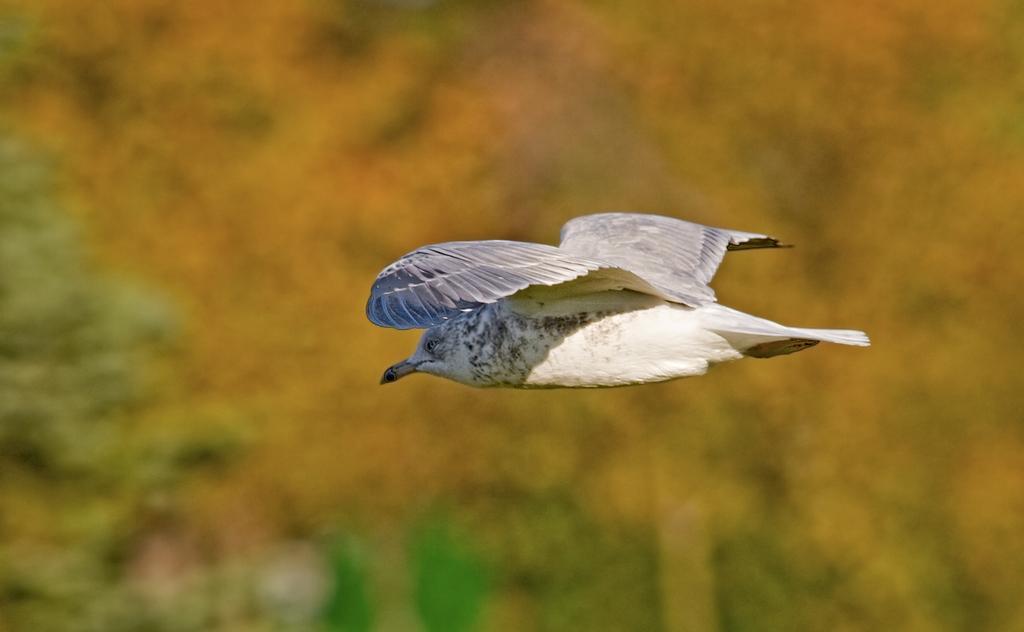How would you summarize this image in a sentence or two? In this image we can see a bird flying and a blurry background. 